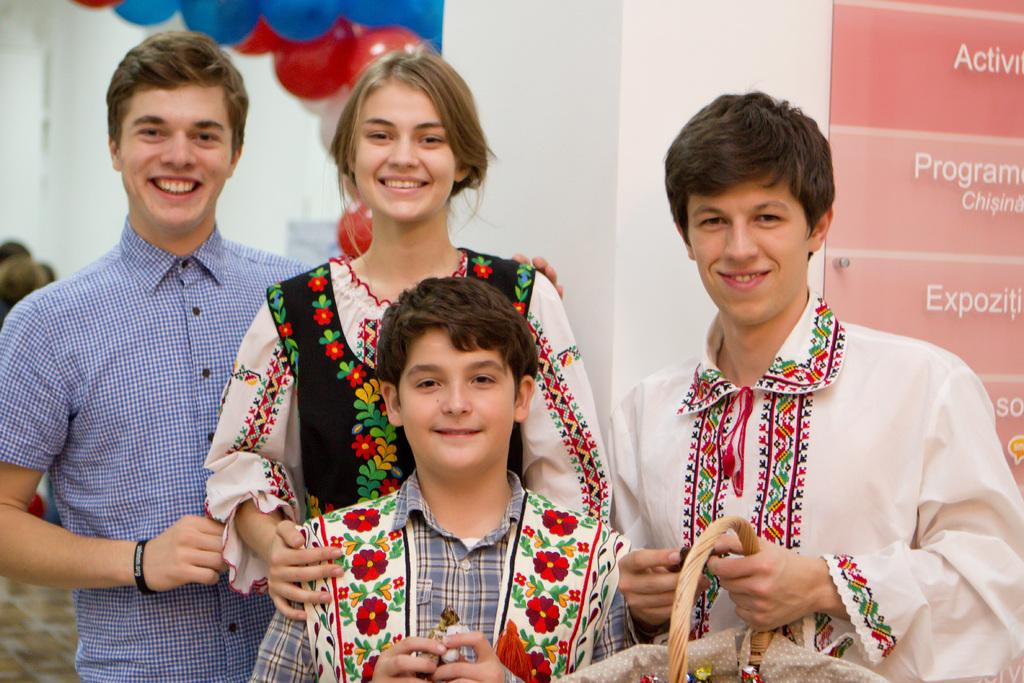What is the main subject of the image? There is a boy standing in the image. Can you describe the girl in the image? There is a girl standing behind the boy in the image, and she is smiling. What is the girl wearing? The girl is wearing a black color dress and another color dress. What else can be seen in the image? There are balloons visible in the image. What type of bells can be heard ringing in the image? There are no bells present in the image, and therefore no sound can be heard. What role does the servant play in the image? There is no servant present in the image. 